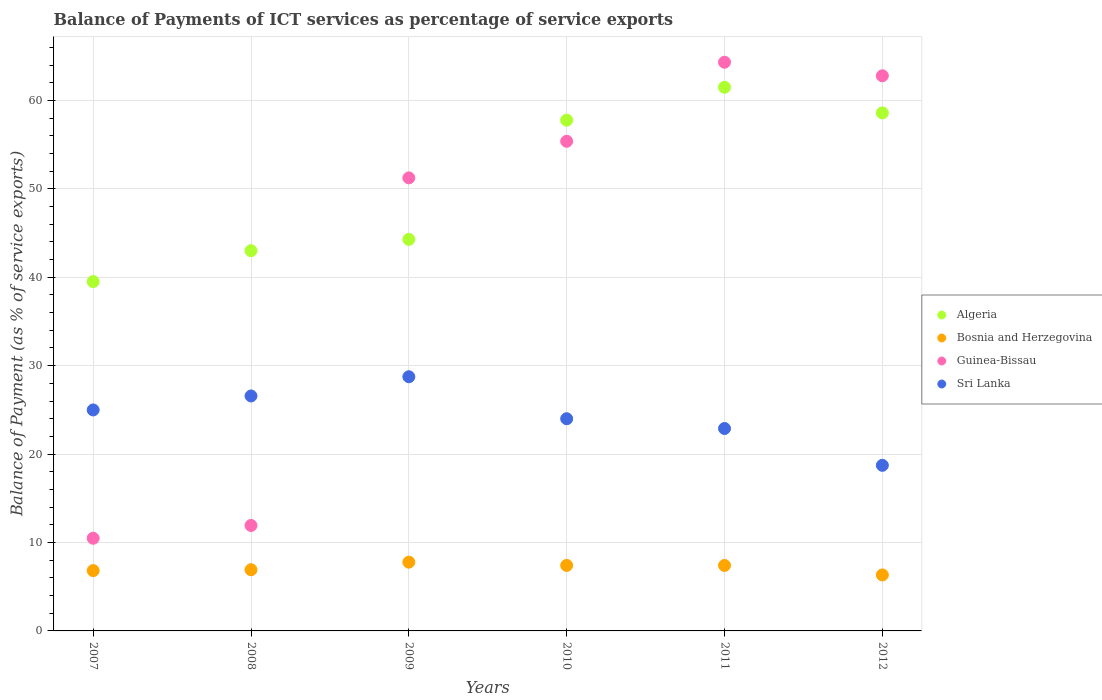What is the balance of payments of ICT services in Bosnia and Herzegovina in 2011?
Offer a very short reply. 7.4. Across all years, what is the maximum balance of payments of ICT services in Bosnia and Herzegovina?
Your answer should be very brief. 7.78. Across all years, what is the minimum balance of payments of ICT services in Algeria?
Offer a terse response. 39.51. In which year was the balance of payments of ICT services in Bosnia and Herzegovina maximum?
Keep it short and to the point. 2009. What is the total balance of payments of ICT services in Algeria in the graph?
Keep it short and to the point. 304.63. What is the difference between the balance of payments of ICT services in Algeria in 2009 and that in 2011?
Offer a terse response. -17.2. What is the difference between the balance of payments of ICT services in Guinea-Bissau in 2010 and the balance of payments of ICT services in Bosnia and Herzegovina in 2008?
Offer a very short reply. 48.46. What is the average balance of payments of ICT services in Bosnia and Herzegovina per year?
Your response must be concise. 7.11. In the year 2011, what is the difference between the balance of payments of ICT services in Bosnia and Herzegovina and balance of payments of ICT services in Algeria?
Keep it short and to the point. -54.08. What is the ratio of the balance of payments of ICT services in Algeria in 2008 to that in 2009?
Offer a terse response. 0.97. Is the balance of payments of ICT services in Bosnia and Herzegovina in 2010 less than that in 2012?
Your answer should be compact. No. Is the difference between the balance of payments of ICT services in Bosnia and Herzegovina in 2008 and 2010 greater than the difference between the balance of payments of ICT services in Algeria in 2008 and 2010?
Provide a short and direct response. Yes. What is the difference between the highest and the second highest balance of payments of ICT services in Guinea-Bissau?
Your answer should be compact. 1.53. What is the difference between the highest and the lowest balance of payments of ICT services in Guinea-Bissau?
Provide a succinct answer. 53.84. Is it the case that in every year, the sum of the balance of payments of ICT services in Sri Lanka and balance of payments of ICT services in Algeria  is greater than the balance of payments of ICT services in Bosnia and Herzegovina?
Offer a terse response. Yes. Does the balance of payments of ICT services in Guinea-Bissau monotonically increase over the years?
Ensure brevity in your answer.  No. How many dotlines are there?
Provide a succinct answer. 4. Does the graph contain any zero values?
Make the answer very short. No. Does the graph contain grids?
Provide a succinct answer. Yes. Where does the legend appear in the graph?
Offer a very short reply. Center right. How many legend labels are there?
Make the answer very short. 4. What is the title of the graph?
Your answer should be compact. Balance of Payments of ICT services as percentage of service exports. What is the label or title of the Y-axis?
Keep it short and to the point. Balance of Payment (as % of service exports). What is the Balance of Payment (as % of service exports) of Algeria in 2007?
Provide a succinct answer. 39.51. What is the Balance of Payment (as % of service exports) in Bosnia and Herzegovina in 2007?
Provide a succinct answer. 6.82. What is the Balance of Payment (as % of service exports) of Guinea-Bissau in 2007?
Give a very brief answer. 10.48. What is the Balance of Payment (as % of service exports) in Sri Lanka in 2007?
Offer a very short reply. 24.99. What is the Balance of Payment (as % of service exports) of Algeria in 2008?
Your response must be concise. 43. What is the Balance of Payment (as % of service exports) of Bosnia and Herzegovina in 2008?
Make the answer very short. 6.92. What is the Balance of Payment (as % of service exports) of Guinea-Bissau in 2008?
Your answer should be compact. 11.93. What is the Balance of Payment (as % of service exports) of Sri Lanka in 2008?
Make the answer very short. 26.57. What is the Balance of Payment (as % of service exports) in Algeria in 2009?
Your answer should be compact. 44.28. What is the Balance of Payment (as % of service exports) in Bosnia and Herzegovina in 2009?
Your answer should be very brief. 7.78. What is the Balance of Payment (as % of service exports) of Guinea-Bissau in 2009?
Keep it short and to the point. 51.24. What is the Balance of Payment (as % of service exports) of Sri Lanka in 2009?
Your answer should be very brief. 28.75. What is the Balance of Payment (as % of service exports) of Algeria in 2010?
Your response must be concise. 57.77. What is the Balance of Payment (as % of service exports) of Bosnia and Herzegovina in 2010?
Keep it short and to the point. 7.41. What is the Balance of Payment (as % of service exports) of Guinea-Bissau in 2010?
Offer a very short reply. 55.38. What is the Balance of Payment (as % of service exports) of Sri Lanka in 2010?
Your answer should be very brief. 24. What is the Balance of Payment (as % of service exports) in Algeria in 2011?
Your response must be concise. 61.48. What is the Balance of Payment (as % of service exports) of Bosnia and Herzegovina in 2011?
Offer a very short reply. 7.4. What is the Balance of Payment (as % of service exports) of Guinea-Bissau in 2011?
Provide a succinct answer. 64.32. What is the Balance of Payment (as % of service exports) of Sri Lanka in 2011?
Make the answer very short. 22.89. What is the Balance of Payment (as % of service exports) in Algeria in 2012?
Give a very brief answer. 58.59. What is the Balance of Payment (as % of service exports) of Bosnia and Herzegovina in 2012?
Keep it short and to the point. 6.33. What is the Balance of Payment (as % of service exports) of Guinea-Bissau in 2012?
Offer a very short reply. 62.79. What is the Balance of Payment (as % of service exports) in Sri Lanka in 2012?
Ensure brevity in your answer.  18.73. Across all years, what is the maximum Balance of Payment (as % of service exports) in Algeria?
Make the answer very short. 61.48. Across all years, what is the maximum Balance of Payment (as % of service exports) in Bosnia and Herzegovina?
Keep it short and to the point. 7.78. Across all years, what is the maximum Balance of Payment (as % of service exports) of Guinea-Bissau?
Offer a very short reply. 64.32. Across all years, what is the maximum Balance of Payment (as % of service exports) of Sri Lanka?
Ensure brevity in your answer.  28.75. Across all years, what is the minimum Balance of Payment (as % of service exports) in Algeria?
Give a very brief answer. 39.51. Across all years, what is the minimum Balance of Payment (as % of service exports) in Bosnia and Herzegovina?
Offer a very short reply. 6.33. Across all years, what is the minimum Balance of Payment (as % of service exports) in Guinea-Bissau?
Give a very brief answer. 10.48. Across all years, what is the minimum Balance of Payment (as % of service exports) of Sri Lanka?
Provide a short and direct response. 18.73. What is the total Balance of Payment (as % of service exports) in Algeria in the graph?
Ensure brevity in your answer.  304.63. What is the total Balance of Payment (as % of service exports) of Bosnia and Herzegovina in the graph?
Provide a succinct answer. 42.66. What is the total Balance of Payment (as % of service exports) in Guinea-Bissau in the graph?
Offer a terse response. 256.13. What is the total Balance of Payment (as % of service exports) in Sri Lanka in the graph?
Your answer should be very brief. 145.93. What is the difference between the Balance of Payment (as % of service exports) of Algeria in 2007 and that in 2008?
Offer a terse response. -3.49. What is the difference between the Balance of Payment (as % of service exports) in Bosnia and Herzegovina in 2007 and that in 2008?
Make the answer very short. -0.1. What is the difference between the Balance of Payment (as % of service exports) of Guinea-Bissau in 2007 and that in 2008?
Your answer should be very brief. -1.44. What is the difference between the Balance of Payment (as % of service exports) of Sri Lanka in 2007 and that in 2008?
Your answer should be very brief. -1.58. What is the difference between the Balance of Payment (as % of service exports) in Algeria in 2007 and that in 2009?
Your answer should be compact. -4.77. What is the difference between the Balance of Payment (as % of service exports) of Bosnia and Herzegovina in 2007 and that in 2009?
Give a very brief answer. -0.95. What is the difference between the Balance of Payment (as % of service exports) of Guinea-Bissau in 2007 and that in 2009?
Offer a terse response. -40.76. What is the difference between the Balance of Payment (as % of service exports) in Sri Lanka in 2007 and that in 2009?
Make the answer very short. -3.75. What is the difference between the Balance of Payment (as % of service exports) of Algeria in 2007 and that in 2010?
Make the answer very short. -18.26. What is the difference between the Balance of Payment (as % of service exports) of Bosnia and Herzegovina in 2007 and that in 2010?
Give a very brief answer. -0.58. What is the difference between the Balance of Payment (as % of service exports) in Guinea-Bissau in 2007 and that in 2010?
Provide a short and direct response. -44.89. What is the difference between the Balance of Payment (as % of service exports) of Algeria in 2007 and that in 2011?
Your answer should be very brief. -21.97. What is the difference between the Balance of Payment (as % of service exports) of Bosnia and Herzegovina in 2007 and that in 2011?
Keep it short and to the point. -0.58. What is the difference between the Balance of Payment (as % of service exports) of Guinea-Bissau in 2007 and that in 2011?
Offer a terse response. -53.84. What is the difference between the Balance of Payment (as % of service exports) of Sri Lanka in 2007 and that in 2011?
Offer a very short reply. 2.1. What is the difference between the Balance of Payment (as % of service exports) in Algeria in 2007 and that in 2012?
Keep it short and to the point. -19.08. What is the difference between the Balance of Payment (as % of service exports) in Bosnia and Herzegovina in 2007 and that in 2012?
Keep it short and to the point. 0.49. What is the difference between the Balance of Payment (as % of service exports) in Guinea-Bissau in 2007 and that in 2012?
Keep it short and to the point. -52.3. What is the difference between the Balance of Payment (as % of service exports) of Sri Lanka in 2007 and that in 2012?
Provide a short and direct response. 6.26. What is the difference between the Balance of Payment (as % of service exports) of Algeria in 2008 and that in 2009?
Ensure brevity in your answer.  -1.28. What is the difference between the Balance of Payment (as % of service exports) of Bosnia and Herzegovina in 2008 and that in 2009?
Ensure brevity in your answer.  -0.85. What is the difference between the Balance of Payment (as % of service exports) in Guinea-Bissau in 2008 and that in 2009?
Your answer should be very brief. -39.31. What is the difference between the Balance of Payment (as % of service exports) of Sri Lanka in 2008 and that in 2009?
Keep it short and to the point. -2.17. What is the difference between the Balance of Payment (as % of service exports) of Algeria in 2008 and that in 2010?
Offer a very short reply. -14.76. What is the difference between the Balance of Payment (as % of service exports) in Bosnia and Herzegovina in 2008 and that in 2010?
Your response must be concise. -0.49. What is the difference between the Balance of Payment (as % of service exports) in Guinea-Bissau in 2008 and that in 2010?
Make the answer very short. -43.45. What is the difference between the Balance of Payment (as % of service exports) in Sri Lanka in 2008 and that in 2010?
Offer a very short reply. 2.58. What is the difference between the Balance of Payment (as % of service exports) in Algeria in 2008 and that in 2011?
Your response must be concise. -18.48. What is the difference between the Balance of Payment (as % of service exports) in Bosnia and Herzegovina in 2008 and that in 2011?
Keep it short and to the point. -0.48. What is the difference between the Balance of Payment (as % of service exports) in Guinea-Bissau in 2008 and that in 2011?
Offer a very short reply. -52.39. What is the difference between the Balance of Payment (as % of service exports) of Sri Lanka in 2008 and that in 2011?
Offer a terse response. 3.68. What is the difference between the Balance of Payment (as % of service exports) of Algeria in 2008 and that in 2012?
Ensure brevity in your answer.  -15.58. What is the difference between the Balance of Payment (as % of service exports) in Bosnia and Herzegovina in 2008 and that in 2012?
Give a very brief answer. 0.59. What is the difference between the Balance of Payment (as % of service exports) in Guinea-Bissau in 2008 and that in 2012?
Make the answer very short. -50.86. What is the difference between the Balance of Payment (as % of service exports) in Sri Lanka in 2008 and that in 2012?
Your response must be concise. 7.84. What is the difference between the Balance of Payment (as % of service exports) of Algeria in 2009 and that in 2010?
Your response must be concise. -13.48. What is the difference between the Balance of Payment (as % of service exports) in Bosnia and Herzegovina in 2009 and that in 2010?
Your answer should be very brief. 0.37. What is the difference between the Balance of Payment (as % of service exports) in Guinea-Bissau in 2009 and that in 2010?
Keep it short and to the point. -4.14. What is the difference between the Balance of Payment (as % of service exports) in Sri Lanka in 2009 and that in 2010?
Give a very brief answer. 4.75. What is the difference between the Balance of Payment (as % of service exports) of Algeria in 2009 and that in 2011?
Give a very brief answer. -17.2. What is the difference between the Balance of Payment (as % of service exports) of Bosnia and Herzegovina in 2009 and that in 2011?
Keep it short and to the point. 0.37. What is the difference between the Balance of Payment (as % of service exports) of Guinea-Bissau in 2009 and that in 2011?
Offer a very short reply. -13.08. What is the difference between the Balance of Payment (as % of service exports) of Sri Lanka in 2009 and that in 2011?
Keep it short and to the point. 5.85. What is the difference between the Balance of Payment (as % of service exports) of Algeria in 2009 and that in 2012?
Make the answer very short. -14.3. What is the difference between the Balance of Payment (as % of service exports) of Bosnia and Herzegovina in 2009 and that in 2012?
Offer a very short reply. 1.45. What is the difference between the Balance of Payment (as % of service exports) in Guinea-Bissau in 2009 and that in 2012?
Offer a terse response. -11.55. What is the difference between the Balance of Payment (as % of service exports) in Sri Lanka in 2009 and that in 2012?
Give a very brief answer. 10.02. What is the difference between the Balance of Payment (as % of service exports) of Algeria in 2010 and that in 2011?
Make the answer very short. -3.72. What is the difference between the Balance of Payment (as % of service exports) in Bosnia and Herzegovina in 2010 and that in 2011?
Your answer should be very brief. 0. What is the difference between the Balance of Payment (as % of service exports) of Guinea-Bissau in 2010 and that in 2011?
Make the answer very short. -8.94. What is the difference between the Balance of Payment (as % of service exports) of Sri Lanka in 2010 and that in 2011?
Your answer should be very brief. 1.1. What is the difference between the Balance of Payment (as % of service exports) in Algeria in 2010 and that in 2012?
Your answer should be compact. -0.82. What is the difference between the Balance of Payment (as % of service exports) of Bosnia and Herzegovina in 2010 and that in 2012?
Ensure brevity in your answer.  1.08. What is the difference between the Balance of Payment (as % of service exports) of Guinea-Bissau in 2010 and that in 2012?
Your response must be concise. -7.41. What is the difference between the Balance of Payment (as % of service exports) of Sri Lanka in 2010 and that in 2012?
Your response must be concise. 5.27. What is the difference between the Balance of Payment (as % of service exports) of Algeria in 2011 and that in 2012?
Your answer should be compact. 2.9. What is the difference between the Balance of Payment (as % of service exports) of Bosnia and Herzegovina in 2011 and that in 2012?
Make the answer very short. 1.07. What is the difference between the Balance of Payment (as % of service exports) of Guinea-Bissau in 2011 and that in 2012?
Your answer should be compact. 1.53. What is the difference between the Balance of Payment (as % of service exports) in Sri Lanka in 2011 and that in 2012?
Make the answer very short. 4.17. What is the difference between the Balance of Payment (as % of service exports) in Algeria in 2007 and the Balance of Payment (as % of service exports) in Bosnia and Herzegovina in 2008?
Your answer should be very brief. 32.59. What is the difference between the Balance of Payment (as % of service exports) of Algeria in 2007 and the Balance of Payment (as % of service exports) of Guinea-Bissau in 2008?
Keep it short and to the point. 27.58. What is the difference between the Balance of Payment (as % of service exports) of Algeria in 2007 and the Balance of Payment (as % of service exports) of Sri Lanka in 2008?
Offer a terse response. 12.94. What is the difference between the Balance of Payment (as % of service exports) of Bosnia and Herzegovina in 2007 and the Balance of Payment (as % of service exports) of Guinea-Bissau in 2008?
Provide a short and direct response. -5.1. What is the difference between the Balance of Payment (as % of service exports) in Bosnia and Herzegovina in 2007 and the Balance of Payment (as % of service exports) in Sri Lanka in 2008?
Your answer should be very brief. -19.75. What is the difference between the Balance of Payment (as % of service exports) in Guinea-Bissau in 2007 and the Balance of Payment (as % of service exports) in Sri Lanka in 2008?
Your response must be concise. -16.09. What is the difference between the Balance of Payment (as % of service exports) in Algeria in 2007 and the Balance of Payment (as % of service exports) in Bosnia and Herzegovina in 2009?
Make the answer very short. 31.73. What is the difference between the Balance of Payment (as % of service exports) of Algeria in 2007 and the Balance of Payment (as % of service exports) of Guinea-Bissau in 2009?
Your response must be concise. -11.73. What is the difference between the Balance of Payment (as % of service exports) of Algeria in 2007 and the Balance of Payment (as % of service exports) of Sri Lanka in 2009?
Your answer should be very brief. 10.76. What is the difference between the Balance of Payment (as % of service exports) of Bosnia and Herzegovina in 2007 and the Balance of Payment (as % of service exports) of Guinea-Bissau in 2009?
Give a very brief answer. -44.42. What is the difference between the Balance of Payment (as % of service exports) of Bosnia and Herzegovina in 2007 and the Balance of Payment (as % of service exports) of Sri Lanka in 2009?
Make the answer very short. -21.93. What is the difference between the Balance of Payment (as % of service exports) in Guinea-Bissau in 2007 and the Balance of Payment (as % of service exports) in Sri Lanka in 2009?
Keep it short and to the point. -18.26. What is the difference between the Balance of Payment (as % of service exports) in Algeria in 2007 and the Balance of Payment (as % of service exports) in Bosnia and Herzegovina in 2010?
Make the answer very short. 32.1. What is the difference between the Balance of Payment (as % of service exports) in Algeria in 2007 and the Balance of Payment (as % of service exports) in Guinea-Bissau in 2010?
Provide a succinct answer. -15.87. What is the difference between the Balance of Payment (as % of service exports) in Algeria in 2007 and the Balance of Payment (as % of service exports) in Sri Lanka in 2010?
Your response must be concise. 15.51. What is the difference between the Balance of Payment (as % of service exports) in Bosnia and Herzegovina in 2007 and the Balance of Payment (as % of service exports) in Guinea-Bissau in 2010?
Offer a very short reply. -48.55. What is the difference between the Balance of Payment (as % of service exports) of Bosnia and Herzegovina in 2007 and the Balance of Payment (as % of service exports) of Sri Lanka in 2010?
Provide a short and direct response. -17.18. What is the difference between the Balance of Payment (as % of service exports) in Guinea-Bissau in 2007 and the Balance of Payment (as % of service exports) in Sri Lanka in 2010?
Offer a very short reply. -13.52. What is the difference between the Balance of Payment (as % of service exports) in Algeria in 2007 and the Balance of Payment (as % of service exports) in Bosnia and Herzegovina in 2011?
Offer a very short reply. 32.11. What is the difference between the Balance of Payment (as % of service exports) of Algeria in 2007 and the Balance of Payment (as % of service exports) of Guinea-Bissau in 2011?
Keep it short and to the point. -24.81. What is the difference between the Balance of Payment (as % of service exports) of Algeria in 2007 and the Balance of Payment (as % of service exports) of Sri Lanka in 2011?
Provide a short and direct response. 16.62. What is the difference between the Balance of Payment (as % of service exports) of Bosnia and Herzegovina in 2007 and the Balance of Payment (as % of service exports) of Guinea-Bissau in 2011?
Your answer should be compact. -57.5. What is the difference between the Balance of Payment (as % of service exports) in Bosnia and Herzegovina in 2007 and the Balance of Payment (as % of service exports) in Sri Lanka in 2011?
Your answer should be compact. -16.07. What is the difference between the Balance of Payment (as % of service exports) in Guinea-Bissau in 2007 and the Balance of Payment (as % of service exports) in Sri Lanka in 2011?
Keep it short and to the point. -12.41. What is the difference between the Balance of Payment (as % of service exports) in Algeria in 2007 and the Balance of Payment (as % of service exports) in Bosnia and Herzegovina in 2012?
Provide a short and direct response. 33.18. What is the difference between the Balance of Payment (as % of service exports) of Algeria in 2007 and the Balance of Payment (as % of service exports) of Guinea-Bissau in 2012?
Give a very brief answer. -23.28. What is the difference between the Balance of Payment (as % of service exports) of Algeria in 2007 and the Balance of Payment (as % of service exports) of Sri Lanka in 2012?
Give a very brief answer. 20.78. What is the difference between the Balance of Payment (as % of service exports) of Bosnia and Herzegovina in 2007 and the Balance of Payment (as % of service exports) of Guinea-Bissau in 2012?
Provide a short and direct response. -55.96. What is the difference between the Balance of Payment (as % of service exports) in Bosnia and Herzegovina in 2007 and the Balance of Payment (as % of service exports) in Sri Lanka in 2012?
Your answer should be very brief. -11.91. What is the difference between the Balance of Payment (as % of service exports) in Guinea-Bissau in 2007 and the Balance of Payment (as % of service exports) in Sri Lanka in 2012?
Your response must be concise. -8.25. What is the difference between the Balance of Payment (as % of service exports) in Algeria in 2008 and the Balance of Payment (as % of service exports) in Bosnia and Herzegovina in 2009?
Keep it short and to the point. 35.23. What is the difference between the Balance of Payment (as % of service exports) of Algeria in 2008 and the Balance of Payment (as % of service exports) of Guinea-Bissau in 2009?
Your answer should be very brief. -8.23. What is the difference between the Balance of Payment (as % of service exports) in Algeria in 2008 and the Balance of Payment (as % of service exports) in Sri Lanka in 2009?
Provide a short and direct response. 14.26. What is the difference between the Balance of Payment (as % of service exports) of Bosnia and Herzegovina in 2008 and the Balance of Payment (as % of service exports) of Guinea-Bissau in 2009?
Provide a succinct answer. -44.32. What is the difference between the Balance of Payment (as % of service exports) of Bosnia and Herzegovina in 2008 and the Balance of Payment (as % of service exports) of Sri Lanka in 2009?
Your response must be concise. -21.83. What is the difference between the Balance of Payment (as % of service exports) in Guinea-Bissau in 2008 and the Balance of Payment (as % of service exports) in Sri Lanka in 2009?
Your answer should be very brief. -16.82. What is the difference between the Balance of Payment (as % of service exports) of Algeria in 2008 and the Balance of Payment (as % of service exports) of Bosnia and Herzegovina in 2010?
Ensure brevity in your answer.  35.6. What is the difference between the Balance of Payment (as % of service exports) of Algeria in 2008 and the Balance of Payment (as % of service exports) of Guinea-Bissau in 2010?
Provide a succinct answer. -12.37. What is the difference between the Balance of Payment (as % of service exports) of Algeria in 2008 and the Balance of Payment (as % of service exports) of Sri Lanka in 2010?
Provide a succinct answer. 19.01. What is the difference between the Balance of Payment (as % of service exports) of Bosnia and Herzegovina in 2008 and the Balance of Payment (as % of service exports) of Guinea-Bissau in 2010?
Give a very brief answer. -48.46. What is the difference between the Balance of Payment (as % of service exports) of Bosnia and Herzegovina in 2008 and the Balance of Payment (as % of service exports) of Sri Lanka in 2010?
Your answer should be very brief. -17.08. What is the difference between the Balance of Payment (as % of service exports) in Guinea-Bissau in 2008 and the Balance of Payment (as % of service exports) in Sri Lanka in 2010?
Offer a very short reply. -12.07. What is the difference between the Balance of Payment (as % of service exports) in Algeria in 2008 and the Balance of Payment (as % of service exports) in Bosnia and Herzegovina in 2011?
Offer a terse response. 35.6. What is the difference between the Balance of Payment (as % of service exports) in Algeria in 2008 and the Balance of Payment (as % of service exports) in Guinea-Bissau in 2011?
Keep it short and to the point. -21.32. What is the difference between the Balance of Payment (as % of service exports) of Algeria in 2008 and the Balance of Payment (as % of service exports) of Sri Lanka in 2011?
Offer a terse response. 20.11. What is the difference between the Balance of Payment (as % of service exports) of Bosnia and Herzegovina in 2008 and the Balance of Payment (as % of service exports) of Guinea-Bissau in 2011?
Your answer should be very brief. -57.4. What is the difference between the Balance of Payment (as % of service exports) of Bosnia and Herzegovina in 2008 and the Balance of Payment (as % of service exports) of Sri Lanka in 2011?
Your response must be concise. -15.97. What is the difference between the Balance of Payment (as % of service exports) of Guinea-Bissau in 2008 and the Balance of Payment (as % of service exports) of Sri Lanka in 2011?
Your answer should be very brief. -10.97. What is the difference between the Balance of Payment (as % of service exports) in Algeria in 2008 and the Balance of Payment (as % of service exports) in Bosnia and Herzegovina in 2012?
Provide a short and direct response. 36.67. What is the difference between the Balance of Payment (as % of service exports) of Algeria in 2008 and the Balance of Payment (as % of service exports) of Guinea-Bissau in 2012?
Offer a terse response. -19.78. What is the difference between the Balance of Payment (as % of service exports) in Algeria in 2008 and the Balance of Payment (as % of service exports) in Sri Lanka in 2012?
Provide a succinct answer. 24.28. What is the difference between the Balance of Payment (as % of service exports) of Bosnia and Herzegovina in 2008 and the Balance of Payment (as % of service exports) of Guinea-Bissau in 2012?
Your answer should be compact. -55.86. What is the difference between the Balance of Payment (as % of service exports) of Bosnia and Herzegovina in 2008 and the Balance of Payment (as % of service exports) of Sri Lanka in 2012?
Your answer should be compact. -11.81. What is the difference between the Balance of Payment (as % of service exports) in Guinea-Bissau in 2008 and the Balance of Payment (as % of service exports) in Sri Lanka in 2012?
Provide a succinct answer. -6.8. What is the difference between the Balance of Payment (as % of service exports) of Algeria in 2009 and the Balance of Payment (as % of service exports) of Bosnia and Herzegovina in 2010?
Offer a very short reply. 36.88. What is the difference between the Balance of Payment (as % of service exports) of Algeria in 2009 and the Balance of Payment (as % of service exports) of Guinea-Bissau in 2010?
Keep it short and to the point. -11.09. What is the difference between the Balance of Payment (as % of service exports) of Algeria in 2009 and the Balance of Payment (as % of service exports) of Sri Lanka in 2010?
Offer a terse response. 20.29. What is the difference between the Balance of Payment (as % of service exports) in Bosnia and Herzegovina in 2009 and the Balance of Payment (as % of service exports) in Guinea-Bissau in 2010?
Your answer should be compact. -47.6. What is the difference between the Balance of Payment (as % of service exports) of Bosnia and Herzegovina in 2009 and the Balance of Payment (as % of service exports) of Sri Lanka in 2010?
Make the answer very short. -16.22. What is the difference between the Balance of Payment (as % of service exports) of Guinea-Bissau in 2009 and the Balance of Payment (as % of service exports) of Sri Lanka in 2010?
Provide a short and direct response. 27.24. What is the difference between the Balance of Payment (as % of service exports) of Algeria in 2009 and the Balance of Payment (as % of service exports) of Bosnia and Herzegovina in 2011?
Ensure brevity in your answer.  36.88. What is the difference between the Balance of Payment (as % of service exports) of Algeria in 2009 and the Balance of Payment (as % of service exports) of Guinea-Bissau in 2011?
Provide a short and direct response. -20.04. What is the difference between the Balance of Payment (as % of service exports) in Algeria in 2009 and the Balance of Payment (as % of service exports) in Sri Lanka in 2011?
Your answer should be compact. 21.39. What is the difference between the Balance of Payment (as % of service exports) in Bosnia and Herzegovina in 2009 and the Balance of Payment (as % of service exports) in Guinea-Bissau in 2011?
Provide a short and direct response. -56.54. What is the difference between the Balance of Payment (as % of service exports) of Bosnia and Herzegovina in 2009 and the Balance of Payment (as % of service exports) of Sri Lanka in 2011?
Make the answer very short. -15.12. What is the difference between the Balance of Payment (as % of service exports) in Guinea-Bissau in 2009 and the Balance of Payment (as % of service exports) in Sri Lanka in 2011?
Make the answer very short. 28.34. What is the difference between the Balance of Payment (as % of service exports) of Algeria in 2009 and the Balance of Payment (as % of service exports) of Bosnia and Herzegovina in 2012?
Ensure brevity in your answer.  37.95. What is the difference between the Balance of Payment (as % of service exports) of Algeria in 2009 and the Balance of Payment (as % of service exports) of Guinea-Bissau in 2012?
Your answer should be compact. -18.5. What is the difference between the Balance of Payment (as % of service exports) of Algeria in 2009 and the Balance of Payment (as % of service exports) of Sri Lanka in 2012?
Your response must be concise. 25.56. What is the difference between the Balance of Payment (as % of service exports) in Bosnia and Herzegovina in 2009 and the Balance of Payment (as % of service exports) in Guinea-Bissau in 2012?
Give a very brief answer. -55.01. What is the difference between the Balance of Payment (as % of service exports) in Bosnia and Herzegovina in 2009 and the Balance of Payment (as % of service exports) in Sri Lanka in 2012?
Provide a short and direct response. -10.95. What is the difference between the Balance of Payment (as % of service exports) of Guinea-Bissau in 2009 and the Balance of Payment (as % of service exports) of Sri Lanka in 2012?
Offer a very short reply. 32.51. What is the difference between the Balance of Payment (as % of service exports) of Algeria in 2010 and the Balance of Payment (as % of service exports) of Bosnia and Herzegovina in 2011?
Your answer should be compact. 50.36. What is the difference between the Balance of Payment (as % of service exports) in Algeria in 2010 and the Balance of Payment (as % of service exports) in Guinea-Bissau in 2011?
Offer a very short reply. -6.55. What is the difference between the Balance of Payment (as % of service exports) in Algeria in 2010 and the Balance of Payment (as % of service exports) in Sri Lanka in 2011?
Make the answer very short. 34.87. What is the difference between the Balance of Payment (as % of service exports) of Bosnia and Herzegovina in 2010 and the Balance of Payment (as % of service exports) of Guinea-Bissau in 2011?
Your answer should be compact. -56.91. What is the difference between the Balance of Payment (as % of service exports) of Bosnia and Herzegovina in 2010 and the Balance of Payment (as % of service exports) of Sri Lanka in 2011?
Keep it short and to the point. -15.49. What is the difference between the Balance of Payment (as % of service exports) of Guinea-Bissau in 2010 and the Balance of Payment (as % of service exports) of Sri Lanka in 2011?
Keep it short and to the point. 32.48. What is the difference between the Balance of Payment (as % of service exports) of Algeria in 2010 and the Balance of Payment (as % of service exports) of Bosnia and Herzegovina in 2012?
Give a very brief answer. 51.43. What is the difference between the Balance of Payment (as % of service exports) of Algeria in 2010 and the Balance of Payment (as % of service exports) of Guinea-Bissau in 2012?
Your response must be concise. -5.02. What is the difference between the Balance of Payment (as % of service exports) of Algeria in 2010 and the Balance of Payment (as % of service exports) of Sri Lanka in 2012?
Offer a terse response. 39.04. What is the difference between the Balance of Payment (as % of service exports) of Bosnia and Herzegovina in 2010 and the Balance of Payment (as % of service exports) of Guinea-Bissau in 2012?
Offer a very short reply. -55.38. What is the difference between the Balance of Payment (as % of service exports) in Bosnia and Herzegovina in 2010 and the Balance of Payment (as % of service exports) in Sri Lanka in 2012?
Your answer should be very brief. -11.32. What is the difference between the Balance of Payment (as % of service exports) in Guinea-Bissau in 2010 and the Balance of Payment (as % of service exports) in Sri Lanka in 2012?
Provide a short and direct response. 36.65. What is the difference between the Balance of Payment (as % of service exports) in Algeria in 2011 and the Balance of Payment (as % of service exports) in Bosnia and Herzegovina in 2012?
Your response must be concise. 55.15. What is the difference between the Balance of Payment (as % of service exports) in Algeria in 2011 and the Balance of Payment (as % of service exports) in Guinea-Bissau in 2012?
Give a very brief answer. -1.3. What is the difference between the Balance of Payment (as % of service exports) in Algeria in 2011 and the Balance of Payment (as % of service exports) in Sri Lanka in 2012?
Your answer should be compact. 42.76. What is the difference between the Balance of Payment (as % of service exports) of Bosnia and Herzegovina in 2011 and the Balance of Payment (as % of service exports) of Guinea-Bissau in 2012?
Offer a terse response. -55.38. What is the difference between the Balance of Payment (as % of service exports) of Bosnia and Herzegovina in 2011 and the Balance of Payment (as % of service exports) of Sri Lanka in 2012?
Make the answer very short. -11.32. What is the difference between the Balance of Payment (as % of service exports) in Guinea-Bissau in 2011 and the Balance of Payment (as % of service exports) in Sri Lanka in 2012?
Your response must be concise. 45.59. What is the average Balance of Payment (as % of service exports) of Algeria per year?
Keep it short and to the point. 50.77. What is the average Balance of Payment (as % of service exports) of Bosnia and Herzegovina per year?
Offer a very short reply. 7.11. What is the average Balance of Payment (as % of service exports) of Guinea-Bissau per year?
Your answer should be very brief. 42.69. What is the average Balance of Payment (as % of service exports) in Sri Lanka per year?
Offer a terse response. 24.32. In the year 2007, what is the difference between the Balance of Payment (as % of service exports) in Algeria and Balance of Payment (as % of service exports) in Bosnia and Herzegovina?
Give a very brief answer. 32.69. In the year 2007, what is the difference between the Balance of Payment (as % of service exports) in Algeria and Balance of Payment (as % of service exports) in Guinea-Bissau?
Make the answer very short. 29.03. In the year 2007, what is the difference between the Balance of Payment (as % of service exports) in Algeria and Balance of Payment (as % of service exports) in Sri Lanka?
Provide a short and direct response. 14.52. In the year 2007, what is the difference between the Balance of Payment (as % of service exports) in Bosnia and Herzegovina and Balance of Payment (as % of service exports) in Guinea-Bissau?
Keep it short and to the point. -3.66. In the year 2007, what is the difference between the Balance of Payment (as % of service exports) in Bosnia and Herzegovina and Balance of Payment (as % of service exports) in Sri Lanka?
Give a very brief answer. -18.17. In the year 2007, what is the difference between the Balance of Payment (as % of service exports) of Guinea-Bissau and Balance of Payment (as % of service exports) of Sri Lanka?
Give a very brief answer. -14.51. In the year 2008, what is the difference between the Balance of Payment (as % of service exports) in Algeria and Balance of Payment (as % of service exports) in Bosnia and Herzegovina?
Make the answer very short. 36.08. In the year 2008, what is the difference between the Balance of Payment (as % of service exports) in Algeria and Balance of Payment (as % of service exports) in Guinea-Bissau?
Make the answer very short. 31.08. In the year 2008, what is the difference between the Balance of Payment (as % of service exports) in Algeria and Balance of Payment (as % of service exports) in Sri Lanka?
Offer a very short reply. 16.43. In the year 2008, what is the difference between the Balance of Payment (as % of service exports) of Bosnia and Herzegovina and Balance of Payment (as % of service exports) of Guinea-Bissau?
Your answer should be very brief. -5. In the year 2008, what is the difference between the Balance of Payment (as % of service exports) of Bosnia and Herzegovina and Balance of Payment (as % of service exports) of Sri Lanka?
Keep it short and to the point. -19.65. In the year 2008, what is the difference between the Balance of Payment (as % of service exports) in Guinea-Bissau and Balance of Payment (as % of service exports) in Sri Lanka?
Provide a short and direct response. -14.65. In the year 2009, what is the difference between the Balance of Payment (as % of service exports) of Algeria and Balance of Payment (as % of service exports) of Bosnia and Herzegovina?
Your response must be concise. 36.51. In the year 2009, what is the difference between the Balance of Payment (as % of service exports) in Algeria and Balance of Payment (as % of service exports) in Guinea-Bissau?
Give a very brief answer. -6.95. In the year 2009, what is the difference between the Balance of Payment (as % of service exports) in Algeria and Balance of Payment (as % of service exports) in Sri Lanka?
Provide a succinct answer. 15.54. In the year 2009, what is the difference between the Balance of Payment (as % of service exports) of Bosnia and Herzegovina and Balance of Payment (as % of service exports) of Guinea-Bissau?
Keep it short and to the point. -43.46. In the year 2009, what is the difference between the Balance of Payment (as % of service exports) in Bosnia and Herzegovina and Balance of Payment (as % of service exports) in Sri Lanka?
Your response must be concise. -20.97. In the year 2009, what is the difference between the Balance of Payment (as % of service exports) of Guinea-Bissau and Balance of Payment (as % of service exports) of Sri Lanka?
Offer a terse response. 22.49. In the year 2010, what is the difference between the Balance of Payment (as % of service exports) in Algeria and Balance of Payment (as % of service exports) in Bosnia and Herzegovina?
Make the answer very short. 50.36. In the year 2010, what is the difference between the Balance of Payment (as % of service exports) in Algeria and Balance of Payment (as % of service exports) in Guinea-Bissau?
Make the answer very short. 2.39. In the year 2010, what is the difference between the Balance of Payment (as % of service exports) of Algeria and Balance of Payment (as % of service exports) of Sri Lanka?
Ensure brevity in your answer.  33.77. In the year 2010, what is the difference between the Balance of Payment (as % of service exports) in Bosnia and Herzegovina and Balance of Payment (as % of service exports) in Guinea-Bissau?
Your answer should be compact. -47.97. In the year 2010, what is the difference between the Balance of Payment (as % of service exports) of Bosnia and Herzegovina and Balance of Payment (as % of service exports) of Sri Lanka?
Offer a very short reply. -16.59. In the year 2010, what is the difference between the Balance of Payment (as % of service exports) of Guinea-Bissau and Balance of Payment (as % of service exports) of Sri Lanka?
Your response must be concise. 31.38. In the year 2011, what is the difference between the Balance of Payment (as % of service exports) of Algeria and Balance of Payment (as % of service exports) of Bosnia and Herzegovina?
Ensure brevity in your answer.  54.08. In the year 2011, what is the difference between the Balance of Payment (as % of service exports) in Algeria and Balance of Payment (as % of service exports) in Guinea-Bissau?
Provide a succinct answer. -2.84. In the year 2011, what is the difference between the Balance of Payment (as % of service exports) in Algeria and Balance of Payment (as % of service exports) in Sri Lanka?
Make the answer very short. 38.59. In the year 2011, what is the difference between the Balance of Payment (as % of service exports) in Bosnia and Herzegovina and Balance of Payment (as % of service exports) in Guinea-Bissau?
Provide a succinct answer. -56.92. In the year 2011, what is the difference between the Balance of Payment (as % of service exports) of Bosnia and Herzegovina and Balance of Payment (as % of service exports) of Sri Lanka?
Offer a terse response. -15.49. In the year 2011, what is the difference between the Balance of Payment (as % of service exports) in Guinea-Bissau and Balance of Payment (as % of service exports) in Sri Lanka?
Provide a succinct answer. 41.43. In the year 2012, what is the difference between the Balance of Payment (as % of service exports) of Algeria and Balance of Payment (as % of service exports) of Bosnia and Herzegovina?
Make the answer very short. 52.26. In the year 2012, what is the difference between the Balance of Payment (as % of service exports) of Algeria and Balance of Payment (as % of service exports) of Guinea-Bissau?
Offer a terse response. -4.2. In the year 2012, what is the difference between the Balance of Payment (as % of service exports) of Algeria and Balance of Payment (as % of service exports) of Sri Lanka?
Provide a succinct answer. 39.86. In the year 2012, what is the difference between the Balance of Payment (as % of service exports) in Bosnia and Herzegovina and Balance of Payment (as % of service exports) in Guinea-Bissau?
Give a very brief answer. -56.45. In the year 2012, what is the difference between the Balance of Payment (as % of service exports) in Bosnia and Herzegovina and Balance of Payment (as % of service exports) in Sri Lanka?
Offer a terse response. -12.4. In the year 2012, what is the difference between the Balance of Payment (as % of service exports) in Guinea-Bissau and Balance of Payment (as % of service exports) in Sri Lanka?
Offer a terse response. 44.06. What is the ratio of the Balance of Payment (as % of service exports) of Algeria in 2007 to that in 2008?
Give a very brief answer. 0.92. What is the ratio of the Balance of Payment (as % of service exports) in Bosnia and Herzegovina in 2007 to that in 2008?
Provide a short and direct response. 0.99. What is the ratio of the Balance of Payment (as % of service exports) in Guinea-Bissau in 2007 to that in 2008?
Make the answer very short. 0.88. What is the ratio of the Balance of Payment (as % of service exports) of Sri Lanka in 2007 to that in 2008?
Give a very brief answer. 0.94. What is the ratio of the Balance of Payment (as % of service exports) in Algeria in 2007 to that in 2009?
Offer a terse response. 0.89. What is the ratio of the Balance of Payment (as % of service exports) in Bosnia and Herzegovina in 2007 to that in 2009?
Make the answer very short. 0.88. What is the ratio of the Balance of Payment (as % of service exports) in Guinea-Bissau in 2007 to that in 2009?
Provide a succinct answer. 0.2. What is the ratio of the Balance of Payment (as % of service exports) of Sri Lanka in 2007 to that in 2009?
Keep it short and to the point. 0.87. What is the ratio of the Balance of Payment (as % of service exports) of Algeria in 2007 to that in 2010?
Provide a succinct answer. 0.68. What is the ratio of the Balance of Payment (as % of service exports) in Bosnia and Herzegovina in 2007 to that in 2010?
Offer a very short reply. 0.92. What is the ratio of the Balance of Payment (as % of service exports) in Guinea-Bissau in 2007 to that in 2010?
Your answer should be very brief. 0.19. What is the ratio of the Balance of Payment (as % of service exports) in Sri Lanka in 2007 to that in 2010?
Provide a succinct answer. 1.04. What is the ratio of the Balance of Payment (as % of service exports) in Algeria in 2007 to that in 2011?
Offer a terse response. 0.64. What is the ratio of the Balance of Payment (as % of service exports) of Bosnia and Herzegovina in 2007 to that in 2011?
Provide a succinct answer. 0.92. What is the ratio of the Balance of Payment (as % of service exports) of Guinea-Bissau in 2007 to that in 2011?
Provide a succinct answer. 0.16. What is the ratio of the Balance of Payment (as % of service exports) of Sri Lanka in 2007 to that in 2011?
Offer a very short reply. 1.09. What is the ratio of the Balance of Payment (as % of service exports) of Algeria in 2007 to that in 2012?
Offer a terse response. 0.67. What is the ratio of the Balance of Payment (as % of service exports) of Bosnia and Herzegovina in 2007 to that in 2012?
Ensure brevity in your answer.  1.08. What is the ratio of the Balance of Payment (as % of service exports) in Guinea-Bissau in 2007 to that in 2012?
Your response must be concise. 0.17. What is the ratio of the Balance of Payment (as % of service exports) of Sri Lanka in 2007 to that in 2012?
Provide a short and direct response. 1.33. What is the ratio of the Balance of Payment (as % of service exports) in Algeria in 2008 to that in 2009?
Offer a very short reply. 0.97. What is the ratio of the Balance of Payment (as % of service exports) in Bosnia and Herzegovina in 2008 to that in 2009?
Ensure brevity in your answer.  0.89. What is the ratio of the Balance of Payment (as % of service exports) of Guinea-Bissau in 2008 to that in 2009?
Offer a very short reply. 0.23. What is the ratio of the Balance of Payment (as % of service exports) of Sri Lanka in 2008 to that in 2009?
Keep it short and to the point. 0.92. What is the ratio of the Balance of Payment (as % of service exports) in Algeria in 2008 to that in 2010?
Offer a very short reply. 0.74. What is the ratio of the Balance of Payment (as % of service exports) in Bosnia and Herzegovina in 2008 to that in 2010?
Offer a terse response. 0.93. What is the ratio of the Balance of Payment (as % of service exports) of Guinea-Bissau in 2008 to that in 2010?
Keep it short and to the point. 0.22. What is the ratio of the Balance of Payment (as % of service exports) in Sri Lanka in 2008 to that in 2010?
Your response must be concise. 1.11. What is the ratio of the Balance of Payment (as % of service exports) of Algeria in 2008 to that in 2011?
Ensure brevity in your answer.  0.7. What is the ratio of the Balance of Payment (as % of service exports) in Bosnia and Herzegovina in 2008 to that in 2011?
Keep it short and to the point. 0.93. What is the ratio of the Balance of Payment (as % of service exports) of Guinea-Bissau in 2008 to that in 2011?
Your answer should be very brief. 0.19. What is the ratio of the Balance of Payment (as % of service exports) of Sri Lanka in 2008 to that in 2011?
Your response must be concise. 1.16. What is the ratio of the Balance of Payment (as % of service exports) of Algeria in 2008 to that in 2012?
Your answer should be compact. 0.73. What is the ratio of the Balance of Payment (as % of service exports) in Bosnia and Herzegovina in 2008 to that in 2012?
Provide a short and direct response. 1.09. What is the ratio of the Balance of Payment (as % of service exports) of Guinea-Bissau in 2008 to that in 2012?
Make the answer very short. 0.19. What is the ratio of the Balance of Payment (as % of service exports) of Sri Lanka in 2008 to that in 2012?
Offer a very short reply. 1.42. What is the ratio of the Balance of Payment (as % of service exports) of Algeria in 2009 to that in 2010?
Offer a terse response. 0.77. What is the ratio of the Balance of Payment (as % of service exports) in Bosnia and Herzegovina in 2009 to that in 2010?
Provide a short and direct response. 1.05. What is the ratio of the Balance of Payment (as % of service exports) in Guinea-Bissau in 2009 to that in 2010?
Ensure brevity in your answer.  0.93. What is the ratio of the Balance of Payment (as % of service exports) of Sri Lanka in 2009 to that in 2010?
Give a very brief answer. 1.2. What is the ratio of the Balance of Payment (as % of service exports) in Algeria in 2009 to that in 2011?
Your answer should be compact. 0.72. What is the ratio of the Balance of Payment (as % of service exports) of Bosnia and Herzegovina in 2009 to that in 2011?
Give a very brief answer. 1.05. What is the ratio of the Balance of Payment (as % of service exports) of Guinea-Bissau in 2009 to that in 2011?
Make the answer very short. 0.8. What is the ratio of the Balance of Payment (as % of service exports) of Sri Lanka in 2009 to that in 2011?
Provide a short and direct response. 1.26. What is the ratio of the Balance of Payment (as % of service exports) of Algeria in 2009 to that in 2012?
Keep it short and to the point. 0.76. What is the ratio of the Balance of Payment (as % of service exports) in Bosnia and Herzegovina in 2009 to that in 2012?
Give a very brief answer. 1.23. What is the ratio of the Balance of Payment (as % of service exports) in Guinea-Bissau in 2009 to that in 2012?
Offer a terse response. 0.82. What is the ratio of the Balance of Payment (as % of service exports) of Sri Lanka in 2009 to that in 2012?
Keep it short and to the point. 1.53. What is the ratio of the Balance of Payment (as % of service exports) of Algeria in 2010 to that in 2011?
Ensure brevity in your answer.  0.94. What is the ratio of the Balance of Payment (as % of service exports) of Guinea-Bissau in 2010 to that in 2011?
Give a very brief answer. 0.86. What is the ratio of the Balance of Payment (as % of service exports) of Sri Lanka in 2010 to that in 2011?
Offer a terse response. 1.05. What is the ratio of the Balance of Payment (as % of service exports) in Bosnia and Herzegovina in 2010 to that in 2012?
Make the answer very short. 1.17. What is the ratio of the Balance of Payment (as % of service exports) in Guinea-Bissau in 2010 to that in 2012?
Your response must be concise. 0.88. What is the ratio of the Balance of Payment (as % of service exports) of Sri Lanka in 2010 to that in 2012?
Make the answer very short. 1.28. What is the ratio of the Balance of Payment (as % of service exports) in Algeria in 2011 to that in 2012?
Give a very brief answer. 1.05. What is the ratio of the Balance of Payment (as % of service exports) in Bosnia and Herzegovina in 2011 to that in 2012?
Your answer should be compact. 1.17. What is the ratio of the Balance of Payment (as % of service exports) of Guinea-Bissau in 2011 to that in 2012?
Your answer should be compact. 1.02. What is the ratio of the Balance of Payment (as % of service exports) of Sri Lanka in 2011 to that in 2012?
Make the answer very short. 1.22. What is the difference between the highest and the second highest Balance of Payment (as % of service exports) in Algeria?
Provide a short and direct response. 2.9. What is the difference between the highest and the second highest Balance of Payment (as % of service exports) in Bosnia and Herzegovina?
Your response must be concise. 0.37. What is the difference between the highest and the second highest Balance of Payment (as % of service exports) in Guinea-Bissau?
Give a very brief answer. 1.53. What is the difference between the highest and the second highest Balance of Payment (as % of service exports) in Sri Lanka?
Your answer should be very brief. 2.17. What is the difference between the highest and the lowest Balance of Payment (as % of service exports) of Algeria?
Keep it short and to the point. 21.97. What is the difference between the highest and the lowest Balance of Payment (as % of service exports) in Bosnia and Herzegovina?
Ensure brevity in your answer.  1.45. What is the difference between the highest and the lowest Balance of Payment (as % of service exports) of Guinea-Bissau?
Your answer should be very brief. 53.84. What is the difference between the highest and the lowest Balance of Payment (as % of service exports) in Sri Lanka?
Keep it short and to the point. 10.02. 